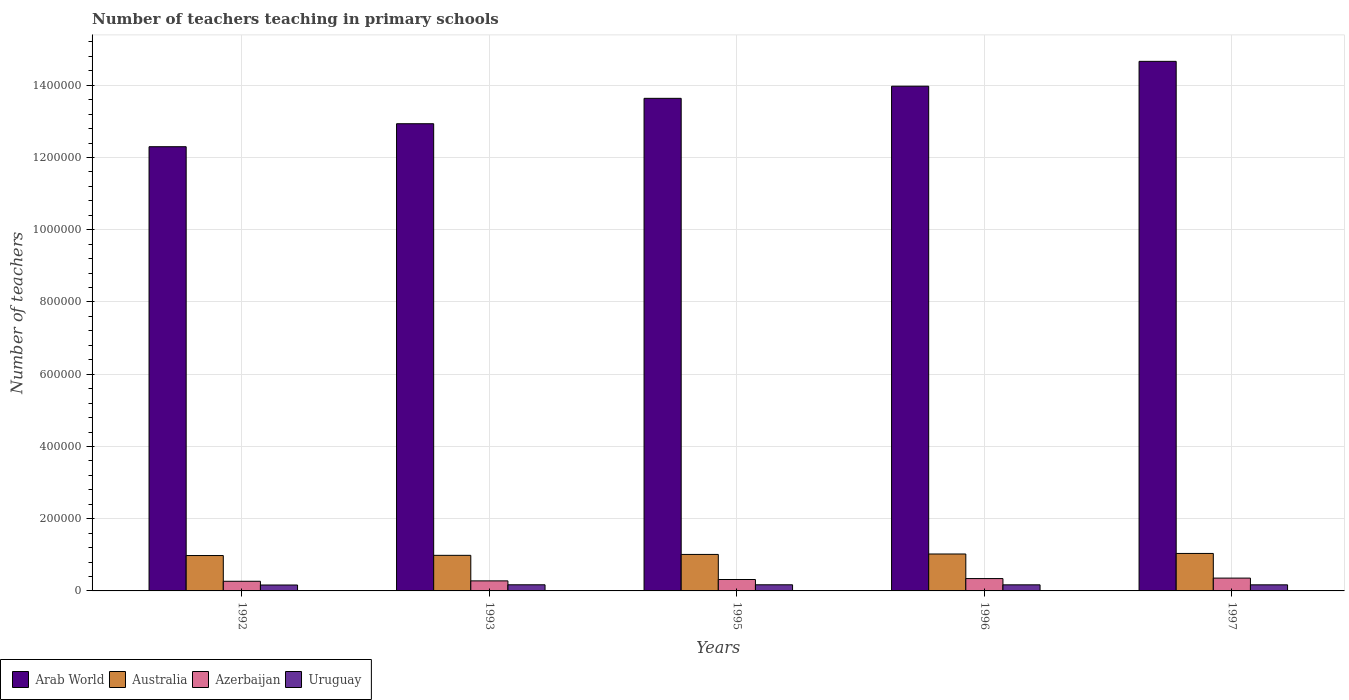How many different coloured bars are there?
Offer a terse response. 4. How many bars are there on the 5th tick from the left?
Offer a terse response. 4. How many bars are there on the 3rd tick from the right?
Your answer should be very brief. 4. What is the number of teachers teaching in primary schools in Azerbaijan in 1997?
Your answer should be compact. 3.55e+04. Across all years, what is the maximum number of teachers teaching in primary schools in Uruguay?
Make the answer very short. 1.70e+04. Across all years, what is the minimum number of teachers teaching in primary schools in Uruguay?
Provide a succinct answer. 1.64e+04. In which year was the number of teachers teaching in primary schools in Australia maximum?
Ensure brevity in your answer.  1997. In which year was the number of teachers teaching in primary schools in Azerbaijan minimum?
Give a very brief answer. 1992. What is the total number of teachers teaching in primary schools in Uruguay in the graph?
Offer a very short reply. 8.41e+04. What is the difference between the number of teachers teaching in primary schools in Arab World in 1992 and that in 1996?
Offer a terse response. -1.68e+05. What is the difference between the number of teachers teaching in primary schools in Arab World in 1997 and the number of teachers teaching in primary schools in Azerbaijan in 1995?
Make the answer very short. 1.43e+06. What is the average number of teachers teaching in primary schools in Australia per year?
Provide a short and direct response. 1.01e+05. In the year 1993, what is the difference between the number of teachers teaching in primary schools in Uruguay and number of teachers teaching in primary schools in Azerbaijan?
Make the answer very short. -1.08e+04. What is the ratio of the number of teachers teaching in primary schools in Azerbaijan in 1996 to that in 1997?
Your response must be concise. 0.96. Is the number of teachers teaching in primary schools in Arab World in 1993 less than that in 1997?
Keep it short and to the point. Yes. What is the difference between the highest and the second highest number of teachers teaching in primary schools in Australia?
Offer a very short reply. 1507. What is the difference between the highest and the lowest number of teachers teaching in primary schools in Arab World?
Keep it short and to the point. 2.36e+05. What does the 4th bar from the left in 1997 represents?
Your answer should be compact. Uruguay. What does the 4th bar from the right in 1993 represents?
Keep it short and to the point. Arab World. Is it the case that in every year, the sum of the number of teachers teaching in primary schools in Arab World and number of teachers teaching in primary schools in Australia is greater than the number of teachers teaching in primary schools in Uruguay?
Ensure brevity in your answer.  Yes. How many years are there in the graph?
Provide a short and direct response. 5. Are the values on the major ticks of Y-axis written in scientific E-notation?
Ensure brevity in your answer.  No. Does the graph contain grids?
Ensure brevity in your answer.  Yes. Where does the legend appear in the graph?
Provide a short and direct response. Bottom left. What is the title of the graph?
Give a very brief answer. Number of teachers teaching in primary schools. Does "St. Kitts and Nevis" appear as one of the legend labels in the graph?
Provide a succinct answer. No. What is the label or title of the Y-axis?
Offer a terse response. Number of teachers. What is the Number of teachers in Arab World in 1992?
Your answer should be very brief. 1.23e+06. What is the Number of teachers in Australia in 1992?
Keep it short and to the point. 9.80e+04. What is the Number of teachers in Azerbaijan in 1992?
Offer a very short reply. 2.67e+04. What is the Number of teachers of Uruguay in 1992?
Your response must be concise. 1.64e+04. What is the Number of teachers in Arab World in 1993?
Your answer should be compact. 1.29e+06. What is the Number of teachers of Australia in 1993?
Provide a short and direct response. 9.85e+04. What is the Number of teachers of Azerbaijan in 1993?
Make the answer very short. 2.78e+04. What is the Number of teachers in Uruguay in 1993?
Make the answer very short. 1.70e+04. What is the Number of teachers of Arab World in 1995?
Your response must be concise. 1.36e+06. What is the Number of teachers in Australia in 1995?
Provide a short and direct response. 1.01e+05. What is the Number of teachers of Azerbaijan in 1995?
Your answer should be very brief. 3.16e+04. What is the Number of teachers of Uruguay in 1995?
Offer a terse response. 1.70e+04. What is the Number of teachers of Arab World in 1996?
Your response must be concise. 1.40e+06. What is the Number of teachers of Australia in 1996?
Your answer should be very brief. 1.02e+05. What is the Number of teachers in Azerbaijan in 1996?
Ensure brevity in your answer.  3.42e+04. What is the Number of teachers of Uruguay in 1996?
Your answer should be compact. 1.69e+04. What is the Number of teachers of Arab World in 1997?
Make the answer very short. 1.47e+06. What is the Number of teachers in Australia in 1997?
Ensure brevity in your answer.  1.04e+05. What is the Number of teachers in Azerbaijan in 1997?
Your answer should be compact. 3.55e+04. What is the Number of teachers in Uruguay in 1997?
Offer a very short reply. 1.69e+04. Across all years, what is the maximum Number of teachers in Arab World?
Make the answer very short. 1.47e+06. Across all years, what is the maximum Number of teachers of Australia?
Your response must be concise. 1.04e+05. Across all years, what is the maximum Number of teachers in Azerbaijan?
Keep it short and to the point. 3.55e+04. Across all years, what is the maximum Number of teachers of Uruguay?
Keep it short and to the point. 1.70e+04. Across all years, what is the minimum Number of teachers of Arab World?
Ensure brevity in your answer.  1.23e+06. Across all years, what is the minimum Number of teachers of Australia?
Offer a terse response. 9.80e+04. Across all years, what is the minimum Number of teachers of Azerbaijan?
Keep it short and to the point. 2.67e+04. Across all years, what is the minimum Number of teachers in Uruguay?
Ensure brevity in your answer.  1.64e+04. What is the total Number of teachers in Arab World in the graph?
Keep it short and to the point. 6.75e+06. What is the total Number of teachers in Australia in the graph?
Your response must be concise. 5.04e+05. What is the total Number of teachers in Azerbaijan in the graph?
Make the answer very short. 1.56e+05. What is the total Number of teachers of Uruguay in the graph?
Offer a terse response. 8.41e+04. What is the difference between the Number of teachers of Arab World in 1992 and that in 1993?
Offer a terse response. -6.36e+04. What is the difference between the Number of teachers in Australia in 1992 and that in 1993?
Ensure brevity in your answer.  -571. What is the difference between the Number of teachers in Azerbaijan in 1992 and that in 1993?
Offer a terse response. -1085. What is the difference between the Number of teachers of Uruguay in 1992 and that in 1993?
Ensure brevity in your answer.  -613. What is the difference between the Number of teachers of Arab World in 1992 and that in 1995?
Offer a very short reply. -1.34e+05. What is the difference between the Number of teachers in Australia in 1992 and that in 1995?
Your answer should be very brief. -3080. What is the difference between the Number of teachers of Azerbaijan in 1992 and that in 1995?
Your answer should be very brief. -4916. What is the difference between the Number of teachers of Uruguay in 1992 and that in 1995?
Keep it short and to the point. -613. What is the difference between the Number of teachers in Arab World in 1992 and that in 1996?
Make the answer very short. -1.68e+05. What is the difference between the Number of teachers of Australia in 1992 and that in 1996?
Your answer should be very brief. -4312. What is the difference between the Number of teachers in Azerbaijan in 1992 and that in 1996?
Your answer should be compact. -7493. What is the difference between the Number of teachers of Uruguay in 1992 and that in 1996?
Give a very brief answer. -490. What is the difference between the Number of teachers in Arab World in 1992 and that in 1997?
Make the answer very short. -2.36e+05. What is the difference between the Number of teachers of Australia in 1992 and that in 1997?
Your answer should be very brief. -5819. What is the difference between the Number of teachers of Azerbaijan in 1992 and that in 1997?
Your answer should be very brief. -8806. What is the difference between the Number of teachers in Uruguay in 1992 and that in 1997?
Offer a very short reply. -491. What is the difference between the Number of teachers of Arab World in 1993 and that in 1995?
Offer a terse response. -7.03e+04. What is the difference between the Number of teachers in Australia in 1993 and that in 1995?
Provide a succinct answer. -2509. What is the difference between the Number of teachers in Azerbaijan in 1993 and that in 1995?
Keep it short and to the point. -3831. What is the difference between the Number of teachers in Arab World in 1993 and that in 1996?
Keep it short and to the point. -1.04e+05. What is the difference between the Number of teachers of Australia in 1993 and that in 1996?
Your response must be concise. -3741. What is the difference between the Number of teachers of Azerbaijan in 1993 and that in 1996?
Make the answer very short. -6408. What is the difference between the Number of teachers in Uruguay in 1993 and that in 1996?
Make the answer very short. 123. What is the difference between the Number of teachers in Arab World in 1993 and that in 1997?
Your response must be concise. -1.73e+05. What is the difference between the Number of teachers of Australia in 1993 and that in 1997?
Make the answer very short. -5248. What is the difference between the Number of teachers in Azerbaijan in 1993 and that in 1997?
Provide a succinct answer. -7721. What is the difference between the Number of teachers of Uruguay in 1993 and that in 1997?
Your answer should be very brief. 122. What is the difference between the Number of teachers in Arab World in 1995 and that in 1996?
Make the answer very short. -3.36e+04. What is the difference between the Number of teachers of Australia in 1995 and that in 1996?
Keep it short and to the point. -1232. What is the difference between the Number of teachers in Azerbaijan in 1995 and that in 1996?
Provide a succinct answer. -2577. What is the difference between the Number of teachers of Uruguay in 1995 and that in 1996?
Offer a terse response. 123. What is the difference between the Number of teachers in Arab World in 1995 and that in 1997?
Provide a succinct answer. -1.02e+05. What is the difference between the Number of teachers of Australia in 1995 and that in 1997?
Your response must be concise. -2739. What is the difference between the Number of teachers of Azerbaijan in 1995 and that in 1997?
Ensure brevity in your answer.  -3890. What is the difference between the Number of teachers of Uruguay in 1995 and that in 1997?
Give a very brief answer. 122. What is the difference between the Number of teachers in Arab World in 1996 and that in 1997?
Your answer should be compact. -6.88e+04. What is the difference between the Number of teachers in Australia in 1996 and that in 1997?
Make the answer very short. -1507. What is the difference between the Number of teachers in Azerbaijan in 1996 and that in 1997?
Your response must be concise. -1313. What is the difference between the Number of teachers in Arab World in 1992 and the Number of teachers in Australia in 1993?
Provide a succinct answer. 1.13e+06. What is the difference between the Number of teachers of Arab World in 1992 and the Number of teachers of Azerbaijan in 1993?
Keep it short and to the point. 1.20e+06. What is the difference between the Number of teachers in Arab World in 1992 and the Number of teachers in Uruguay in 1993?
Your answer should be compact. 1.21e+06. What is the difference between the Number of teachers of Australia in 1992 and the Number of teachers of Azerbaijan in 1993?
Provide a short and direct response. 7.02e+04. What is the difference between the Number of teachers of Australia in 1992 and the Number of teachers of Uruguay in 1993?
Provide a succinct answer. 8.10e+04. What is the difference between the Number of teachers in Azerbaijan in 1992 and the Number of teachers in Uruguay in 1993?
Provide a short and direct response. 9717. What is the difference between the Number of teachers of Arab World in 1992 and the Number of teachers of Australia in 1995?
Provide a succinct answer. 1.13e+06. What is the difference between the Number of teachers of Arab World in 1992 and the Number of teachers of Azerbaijan in 1995?
Give a very brief answer. 1.20e+06. What is the difference between the Number of teachers of Arab World in 1992 and the Number of teachers of Uruguay in 1995?
Your response must be concise. 1.21e+06. What is the difference between the Number of teachers of Australia in 1992 and the Number of teachers of Azerbaijan in 1995?
Your answer should be very brief. 6.63e+04. What is the difference between the Number of teachers of Australia in 1992 and the Number of teachers of Uruguay in 1995?
Offer a very short reply. 8.10e+04. What is the difference between the Number of teachers of Azerbaijan in 1992 and the Number of teachers of Uruguay in 1995?
Offer a very short reply. 9717. What is the difference between the Number of teachers of Arab World in 1992 and the Number of teachers of Australia in 1996?
Your answer should be compact. 1.13e+06. What is the difference between the Number of teachers of Arab World in 1992 and the Number of teachers of Azerbaijan in 1996?
Keep it short and to the point. 1.20e+06. What is the difference between the Number of teachers of Arab World in 1992 and the Number of teachers of Uruguay in 1996?
Your response must be concise. 1.21e+06. What is the difference between the Number of teachers in Australia in 1992 and the Number of teachers in Azerbaijan in 1996?
Offer a very short reply. 6.38e+04. What is the difference between the Number of teachers in Australia in 1992 and the Number of teachers in Uruguay in 1996?
Keep it short and to the point. 8.11e+04. What is the difference between the Number of teachers of Azerbaijan in 1992 and the Number of teachers of Uruguay in 1996?
Provide a short and direct response. 9840. What is the difference between the Number of teachers in Arab World in 1992 and the Number of teachers in Australia in 1997?
Offer a terse response. 1.13e+06. What is the difference between the Number of teachers in Arab World in 1992 and the Number of teachers in Azerbaijan in 1997?
Your response must be concise. 1.19e+06. What is the difference between the Number of teachers in Arab World in 1992 and the Number of teachers in Uruguay in 1997?
Make the answer very short. 1.21e+06. What is the difference between the Number of teachers in Australia in 1992 and the Number of teachers in Azerbaijan in 1997?
Your answer should be compact. 6.24e+04. What is the difference between the Number of teachers in Australia in 1992 and the Number of teachers in Uruguay in 1997?
Provide a succinct answer. 8.11e+04. What is the difference between the Number of teachers in Azerbaijan in 1992 and the Number of teachers in Uruguay in 1997?
Offer a terse response. 9839. What is the difference between the Number of teachers of Arab World in 1993 and the Number of teachers of Australia in 1995?
Keep it short and to the point. 1.19e+06. What is the difference between the Number of teachers of Arab World in 1993 and the Number of teachers of Azerbaijan in 1995?
Offer a terse response. 1.26e+06. What is the difference between the Number of teachers of Arab World in 1993 and the Number of teachers of Uruguay in 1995?
Your response must be concise. 1.28e+06. What is the difference between the Number of teachers in Australia in 1993 and the Number of teachers in Azerbaijan in 1995?
Provide a short and direct response. 6.69e+04. What is the difference between the Number of teachers in Australia in 1993 and the Number of teachers in Uruguay in 1995?
Your response must be concise. 8.15e+04. What is the difference between the Number of teachers of Azerbaijan in 1993 and the Number of teachers of Uruguay in 1995?
Provide a short and direct response. 1.08e+04. What is the difference between the Number of teachers in Arab World in 1993 and the Number of teachers in Australia in 1996?
Ensure brevity in your answer.  1.19e+06. What is the difference between the Number of teachers in Arab World in 1993 and the Number of teachers in Azerbaijan in 1996?
Provide a short and direct response. 1.26e+06. What is the difference between the Number of teachers in Arab World in 1993 and the Number of teachers in Uruguay in 1996?
Provide a short and direct response. 1.28e+06. What is the difference between the Number of teachers of Australia in 1993 and the Number of teachers of Azerbaijan in 1996?
Ensure brevity in your answer.  6.43e+04. What is the difference between the Number of teachers of Australia in 1993 and the Number of teachers of Uruguay in 1996?
Keep it short and to the point. 8.17e+04. What is the difference between the Number of teachers in Azerbaijan in 1993 and the Number of teachers in Uruguay in 1996?
Offer a very short reply. 1.09e+04. What is the difference between the Number of teachers of Arab World in 1993 and the Number of teachers of Australia in 1997?
Provide a succinct answer. 1.19e+06. What is the difference between the Number of teachers in Arab World in 1993 and the Number of teachers in Azerbaijan in 1997?
Provide a succinct answer. 1.26e+06. What is the difference between the Number of teachers in Arab World in 1993 and the Number of teachers in Uruguay in 1997?
Provide a succinct answer. 1.28e+06. What is the difference between the Number of teachers of Australia in 1993 and the Number of teachers of Azerbaijan in 1997?
Offer a terse response. 6.30e+04. What is the difference between the Number of teachers in Australia in 1993 and the Number of teachers in Uruguay in 1997?
Your response must be concise. 8.17e+04. What is the difference between the Number of teachers in Azerbaijan in 1993 and the Number of teachers in Uruguay in 1997?
Provide a succinct answer. 1.09e+04. What is the difference between the Number of teachers of Arab World in 1995 and the Number of teachers of Australia in 1996?
Your response must be concise. 1.26e+06. What is the difference between the Number of teachers in Arab World in 1995 and the Number of teachers in Azerbaijan in 1996?
Give a very brief answer. 1.33e+06. What is the difference between the Number of teachers in Arab World in 1995 and the Number of teachers in Uruguay in 1996?
Your answer should be very brief. 1.35e+06. What is the difference between the Number of teachers in Australia in 1995 and the Number of teachers in Azerbaijan in 1996?
Your response must be concise. 6.68e+04. What is the difference between the Number of teachers in Australia in 1995 and the Number of teachers in Uruguay in 1996?
Give a very brief answer. 8.42e+04. What is the difference between the Number of teachers in Azerbaijan in 1995 and the Number of teachers in Uruguay in 1996?
Ensure brevity in your answer.  1.48e+04. What is the difference between the Number of teachers in Arab World in 1995 and the Number of teachers in Australia in 1997?
Keep it short and to the point. 1.26e+06. What is the difference between the Number of teachers of Arab World in 1995 and the Number of teachers of Azerbaijan in 1997?
Offer a terse response. 1.33e+06. What is the difference between the Number of teachers in Arab World in 1995 and the Number of teachers in Uruguay in 1997?
Keep it short and to the point. 1.35e+06. What is the difference between the Number of teachers of Australia in 1995 and the Number of teachers of Azerbaijan in 1997?
Give a very brief answer. 6.55e+04. What is the difference between the Number of teachers in Australia in 1995 and the Number of teachers in Uruguay in 1997?
Offer a very short reply. 8.42e+04. What is the difference between the Number of teachers in Azerbaijan in 1995 and the Number of teachers in Uruguay in 1997?
Give a very brief answer. 1.48e+04. What is the difference between the Number of teachers in Arab World in 1996 and the Number of teachers in Australia in 1997?
Provide a succinct answer. 1.29e+06. What is the difference between the Number of teachers in Arab World in 1996 and the Number of teachers in Azerbaijan in 1997?
Offer a very short reply. 1.36e+06. What is the difference between the Number of teachers of Arab World in 1996 and the Number of teachers of Uruguay in 1997?
Provide a short and direct response. 1.38e+06. What is the difference between the Number of teachers in Australia in 1996 and the Number of teachers in Azerbaijan in 1997?
Keep it short and to the point. 6.68e+04. What is the difference between the Number of teachers in Australia in 1996 and the Number of teachers in Uruguay in 1997?
Your answer should be compact. 8.54e+04. What is the difference between the Number of teachers of Azerbaijan in 1996 and the Number of teachers of Uruguay in 1997?
Your response must be concise. 1.73e+04. What is the average Number of teachers of Arab World per year?
Offer a very short reply. 1.35e+06. What is the average Number of teachers of Australia per year?
Provide a short and direct response. 1.01e+05. What is the average Number of teachers in Azerbaijan per year?
Your answer should be compact. 3.12e+04. What is the average Number of teachers of Uruguay per year?
Your answer should be compact. 1.68e+04. In the year 1992, what is the difference between the Number of teachers in Arab World and Number of teachers in Australia?
Your response must be concise. 1.13e+06. In the year 1992, what is the difference between the Number of teachers in Arab World and Number of teachers in Azerbaijan?
Make the answer very short. 1.20e+06. In the year 1992, what is the difference between the Number of teachers of Arab World and Number of teachers of Uruguay?
Offer a very short reply. 1.21e+06. In the year 1992, what is the difference between the Number of teachers of Australia and Number of teachers of Azerbaijan?
Your response must be concise. 7.12e+04. In the year 1992, what is the difference between the Number of teachers of Australia and Number of teachers of Uruguay?
Ensure brevity in your answer.  8.16e+04. In the year 1992, what is the difference between the Number of teachers in Azerbaijan and Number of teachers in Uruguay?
Offer a terse response. 1.03e+04. In the year 1993, what is the difference between the Number of teachers of Arab World and Number of teachers of Australia?
Ensure brevity in your answer.  1.20e+06. In the year 1993, what is the difference between the Number of teachers of Arab World and Number of teachers of Azerbaijan?
Make the answer very short. 1.27e+06. In the year 1993, what is the difference between the Number of teachers in Arab World and Number of teachers in Uruguay?
Your response must be concise. 1.28e+06. In the year 1993, what is the difference between the Number of teachers of Australia and Number of teachers of Azerbaijan?
Offer a very short reply. 7.07e+04. In the year 1993, what is the difference between the Number of teachers of Australia and Number of teachers of Uruguay?
Ensure brevity in your answer.  8.15e+04. In the year 1993, what is the difference between the Number of teachers of Azerbaijan and Number of teachers of Uruguay?
Your answer should be compact. 1.08e+04. In the year 1995, what is the difference between the Number of teachers of Arab World and Number of teachers of Australia?
Give a very brief answer. 1.26e+06. In the year 1995, what is the difference between the Number of teachers in Arab World and Number of teachers in Azerbaijan?
Provide a short and direct response. 1.33e+06. In the year 1995, what is the difference between the Number of teachers of Arab World and Number of teachers of Uruguay?
Keep it short and to the point. 1.35e+06. In the year 1995, what is the difference between the Number of teachers in Australia and Number of teachers in Azerbaijan?
Make the answer very short. 6.94e+04. In the year 1995, what is the difference between the Number of teachers in Australia and Number of teachers in Uruguay?
Keep it short and to the point. 8.40e+04. In the year 1995, what is the difference between the Number of teachers in Azerbaijan and Number of teachers in Uruguay?
Your answer should be compact. 1.46e+04. In the year 1996, what is the difference between the Number of teachers of Arab World and Number of teachers of Australia?
Ensure brevity in your answer.  1.30e+06. In the year 1996, what is the difference between the Number of teachers in Arab World and Number of teachers in Azerbaijan?
Keep it short and to the point. 1.36e+06. In the year 1996, what is the difference between the Number of teachers of Arab World and Number of teachers of Uruguay?
Provide a succinct answer. 1.38e+06. In the year 1996, what is the difference between the Number of teachers in Australia and Number of teachers in Azerbaijan?
Provide a short and direct response. 6.81e+04. In the year 1996, what is the difference between the Number of teachers of Australia and Number of teachers of Uruguay?
Ensure brevity in your answer.  8.54e+04. In the year 1996, what is the difference between the Number of teachers of Azerbaijan and Number of teachers of Uruguay?
Offer a terse response. 1.73e+04. In the year 1997, what is the difference between the Number of teachers in Arab World and Number of teachers in Australia?
Offer a very short reply. 1.36e+06. In the year 1997, what is the difference between the Number of teachers of Arab World and Number of teachers of Azerbaijan?
Offer a terse response. 1.43e+06. In the year 1997, what is the difference between the Number of teachers in Arab World and Number of teachers in Uruguay?
Offer a terse response. 1.45e+06. In the year 1997, what is the difference between the Number of teachers of Australia and Number of teachers of Azerbaijan?
Your response must be concise. 6.83e+04. In the year 1997, what is the difference between the Number of teachers in Australia and Number of teachers in Uruguay?
Give a very brief answer. 8.69e+04. In the year 1997, what is the difference between the Number of teachers of Azerbaijan and Number of teachers of Uruguay?
Ensure brevity in your answer.  1.86e+04. What is the ratio of the Number of teachers of Arab World in 1992 to that in 1993?
Offer a very short reply. 0.95. What is the ratio of the Number of teachers of Azerbaijan in 1992 to that in 1993?
Give a very brief answer. 0.96. What is the ratio of the Number of teachers in Uruguay in 1992 to that in 1993?
Offer a very short reply. 0.96. What is the ratio of the Number of teachers in Arab World in 1992 to that in 1995?
Provide a short and direct response. 0.9. What is the ratio of the Number of teachers of Australia in 1992 to that in 1995?
Your answer should be very brief. 0.97. What is the ratio of the Number of teachers in Azerbaijan in 1992 to that in 1995?
Provide a short and direct response. 0.84. What is the ratio of the Number of teachers in Uruguay in 1992 to that in 1995?
Ensure brevity in your answer.  0.96. What is the ratio of the Number of teachers of Arab World in 1992 to that in 1996?
Keep it short and to the point. 0.88. What is the ratio of the Number of teachers in Australia in 1992 to that in 1996?
Keep it short and to the point. 0.96. What is the ratio of the Number of teachers of Azerbaijan in 1992 to that in 1996?
Keep it short and to the point. 0.78. What is the ratio of the Number of teachers of Uruguay in 1992 to that in 1996?
Offer a terse response. 0.97. What is the ratio of the Number of teachers in Arab World in 1992 to that in 1997?
Your answer should be compact. 0.84. What is the ratio of the Number of teachers in Australia in 1992 to that in 1997?
Make the answer very short. 0.94. What is the ratio of the Number of teachers in Azerbaijan in 1992 to that in 1997?
Offer a very short reply. 0.75. What is the ratio of the Number of teachers in Uruguay in 1992 to that in 1997?
Provide a succinct answer. 0.97. What is the ratio of the Number of teachers in Arab World in 1993 to that in 1995?
Provide a succinct answer. 0.95. What is the ratio of the Number of teachers in Australia in 1993 to that in 1995?
Your answer should be very brief. 0.98. What is the ratio of the Number of teachers of Azerbaijan in 1993 to that in 1995?
Offer a very short reply. 0.88. What is the ratio of the Number of teachers of Arab World in 1993 to that in 1996?
Provide a short and direct response. 0.93. What is the ratio of the Number of teachers in Australia in 1993 to that in 1996?
Your response must be concise. 0.96. What is the ratio of the Number of teachers of Azerbaijan in 1993 to that in 1996?
Your answer should be very brief. 0.81. What is the ratio of the Number of teachers of Uruguay in 1993 to that in 1996?
Your answer should be very brief. 1.01. What is the ratio of the Number of teachers of Arab World in 1993 to that in 1997?
Make the answer very short. 0.88. What is the ratio of the Number of teachers in Australia in 1993 to that in 1997?
Provide a short and direct response. 0.95. What is the ratio of the Number of teachers in Azerbaijan in 1993 to that in 1997?
Provide a short and direct response. 0.78. What is the ratio of the Number of teachers in Uruguay in 1993 to that in 1997?
Offer a very short reply. 1.01. What is the ratio of the Number of teachers of Arab World in 1995 to that in 1996?
Provide a short and direct response. 0.98. What is the ratio of the Number of teachers of Azerbaijan in 1995 to that in 1996?
Your response must be concise. 0.92. What is the ratio of the Number of teachers of Uruguay in 1995 to that in 1996?
Your answer should be very brief. 1.01. What is the ratio of the Number of teachers in Arab World in 1995 to that in 1997?
Ensure brevity in your answer.  0.93. What is the ratio of the Number of teachers of Australia in 1995 to that in 1997?
Keep it short and to the point. 0.97. What is the ratio of the Number of teachers in Azerbaijan in 1995 to that in 1997?
Keep it short and to the point. 0.89. What is the ratio of the Number of teachers of Uruguay in 1995 to that in 1997?
Your response must be concise. 1.01. What is the ratio of the Number of teachers of Arab World in 1996 to that in 1997?
Ensure brevity in your answer.  0.95. What is the ratio of the Number of teachers of Australia in 1996 to that in 1997?
Make the answer very short. 0.99. What is the ratio of the Number of teachers in Azerbaijan in 1996 to that in 1997?
Offer a terse response. 0.96. What is the difference between the highest and the second highest Number of teachers in Arab World?
Ensure brevity in your answer.  6.88e+04. What is the difference between the highest and the second highest Number of teachers of Australia?
Offer a very short reply. 1507. What is the difference between the highest and the second highest Number of teachers of Azerbaijan?
Make the answer very short. 1313. What is the difference between the highest and the lowest Number of teachers of Arab World?
Make the answer very short. 2.36e+05. What is the difference between the highest and the lowest Number of teachers of Australia?
Your answer should be very brief. 5819. What is the difference between the highest and the lowest Number of teachers of Azerbaijan?
Ensure brevity in your answer.  8806. What is the difference between the highest and the lowest Number of teachers in Uruguay?
Keep it short and to the point. 613. 